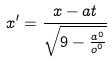<formula> <loc_0><loc_0><loc_500><loc_500>x ^ { \prime } = \frac { x - a t } { \sqrt { 9 - \frac { a ^ { 0 } } { o ^ { 0 } } } }</formula> 